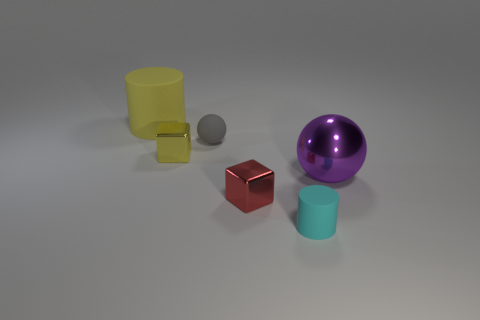There is another large object that is made of the same material as the cyan thing; what shape is it?
Offer a very short reply. Cylinder. Are the large thing that is left of the tiny rubber cylinder and the small red cube made of the same material?
Make the answer very short. No. What is the shape of the tiny metal thing that is the same color as the big cylinder?
Offer a very short reply. Cube. There is a large object that is on the right side of the large yellow rubber cylinder; is its color the same as the small shiny block behind the purple metal sphere?
Your response must be concise. No. How many cylinders are in front of the purple metallic thing and to the left of the tiny cyan rubber cylinder?
Offer a terse response. 0. What material is the small yellow block?
Give a very brief answer. Metal. The red object that is the same size as the cyan rubber cylinder is what shape?
Make the answer very short. Cube. Is the small thing on the left side of the gray object made of the same material as the big thing that is to the right of the tiny yellow metallic thing?
Keep it short and to the point. Yes. What number of large purple things are there?
Your answer should be compact. 1. What number of tiny yellow shiny things are the same shape as the gray matte thing?
Your answer should be compact. 0. 